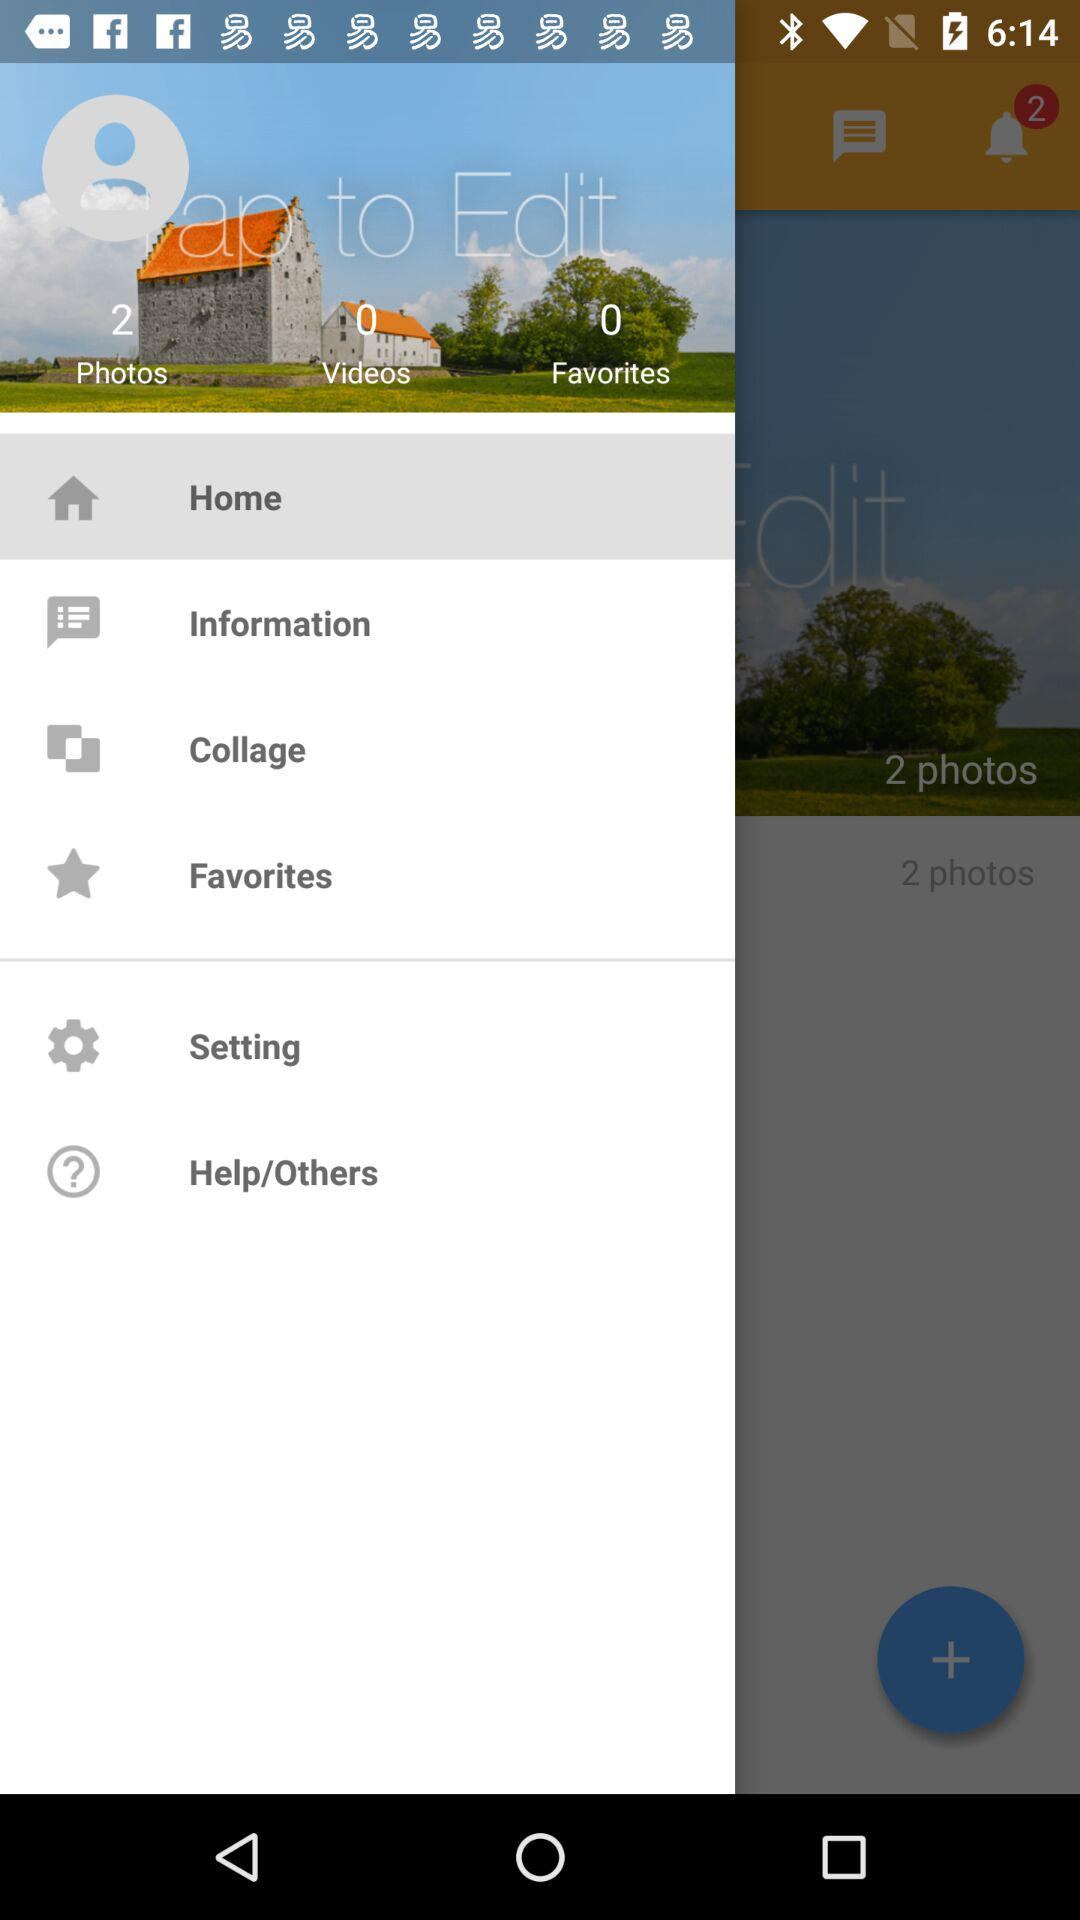How many more photos than videos are there?
Answer the question using a single word or phrase. 2 